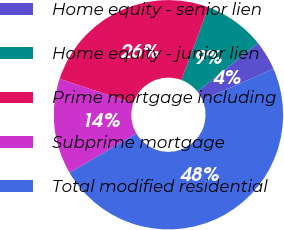Convert chart. <chart><loc_0><loc_0><loc_500><loc_500><pie_chart><fcel>Home equity - senior lien<fcel>Home equity - junior lien<fcel>Prime mortgage including<fcel>Subprime mortgage<fcel>Total modified residential<nl><fcel>4.19%<fcel>8.58%<fcel>25.6%<fcel>13.51%<fcel>48.12%<nl></chart> 